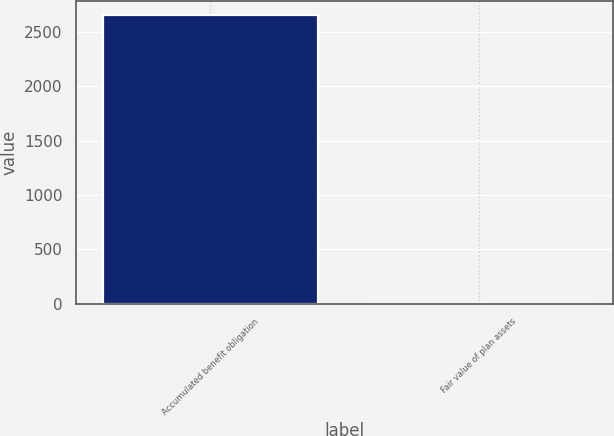<chart> <loc_0><loc_0><loc_500><loc_500><bar_chart><fcel>Accumulated benefit obligation<fcel>Fair value of plan assets<nl><fcel>2655<fcel>2.75<nl></chart> 